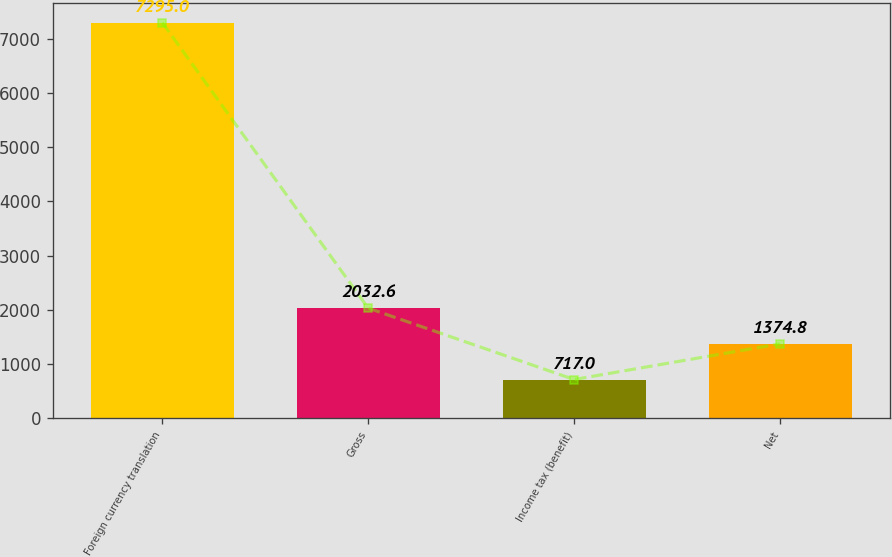Convert chart. <chart><loc_0><loc_0><loc_500><loc_500><bar_chart><fcel>Foreign currency translation<fcel>Gross<fcel>Income tax (benefit)<fcel>Net<nl><fcel>7295<fcel>2032.6<fcel>717<fcel>1374.8<nl></chart> 